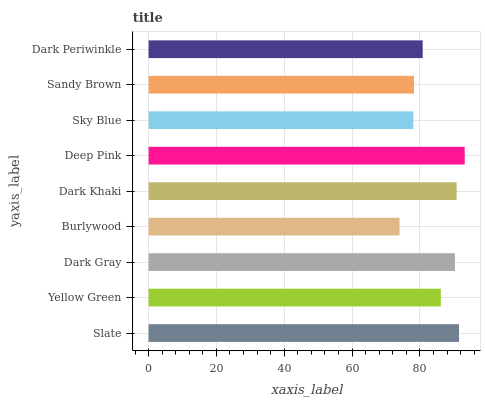Is Burlywood the minimum?
Answer yes or no. Yes. Is Deep Pink the maximum?
Answer yes or no. Yes. Is Yellow Green the minimum?
Answer yes or no. No. Is Yellow Green the maximum?
Answer yes or no. No. Is Slate greater than Yellow Green?
Answer yes or no. Yes. Is Yellow Green less than Slate?
Answer yes or no. Yes. Is Yellow Green greater than Slate?
Answer yes or no. No. Is Slate less than Yellow Green?
Answer yes or no. No. Is Yellow Green the high median?
Answer yes or no. Yes. Is Yellow Green the low median?
Answer yes or no. Yes. Is Dark Periwinkle the high median?
Answer yes or no. No. Is Dark Periwinkle the low median?
Answer yes or no. No. 